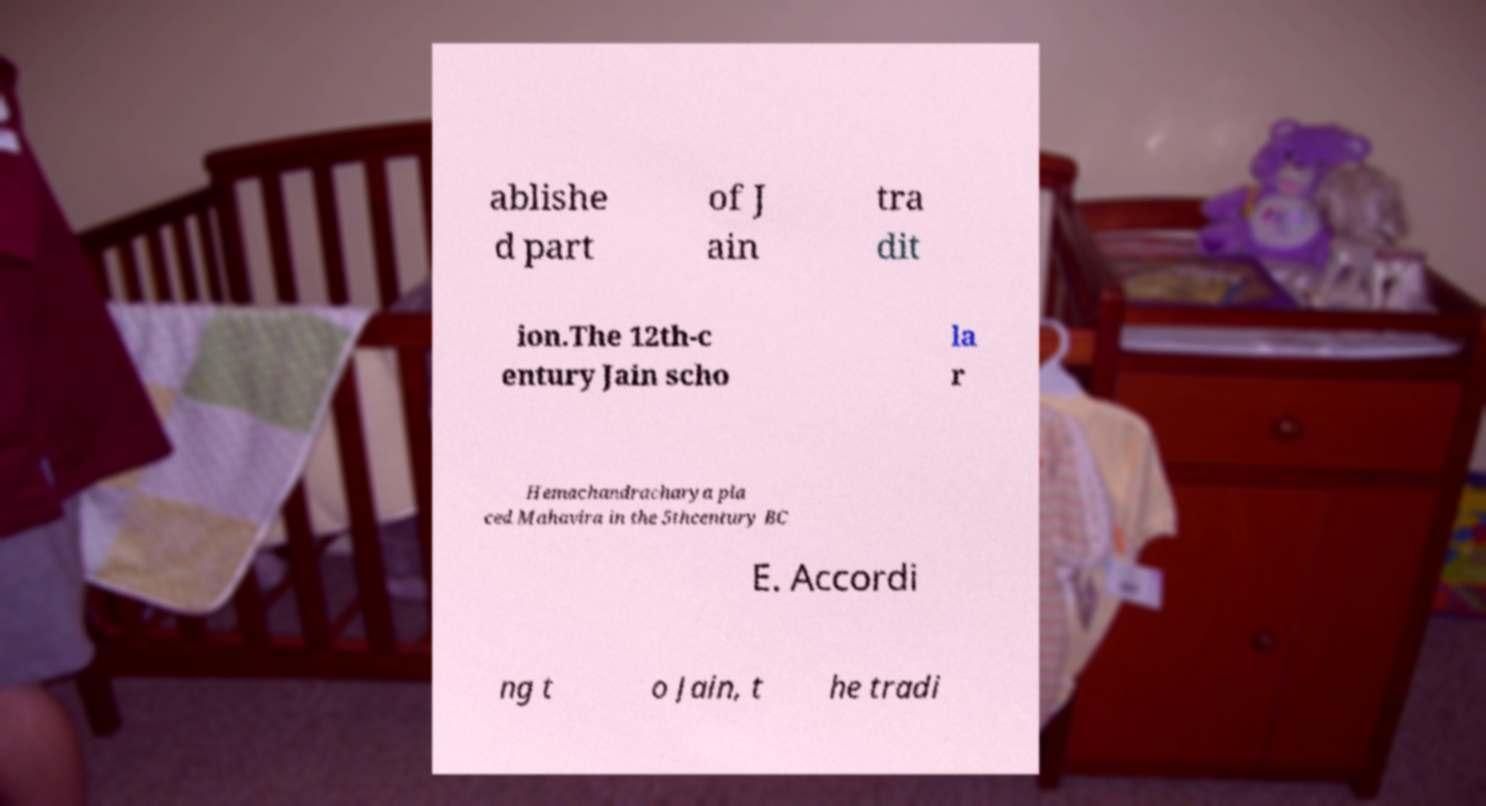Please read and relay the text visible in this image. What does it say? ablishe d part of J ain tra dit ion.The 12th-c entury Jain scho la r Hemachandracharya pla ced Mahavira in the 5thcentury BC E. Accordi ng t o Jain, t he tradi 